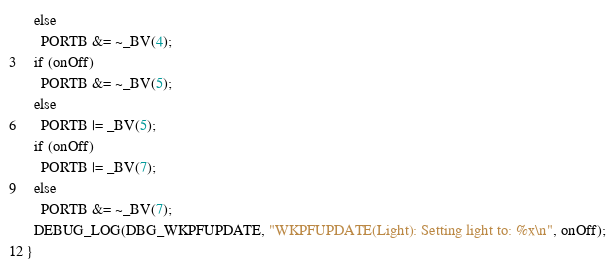<code> <loc_0><loc_0><loc_500><loc_500><_C_>  else
    PORTB &= ~_BV(4);
  if (onOff)
    PORTB &= ~_BV(5);
  else
    PORTB |= _BV(5);
  if (onOff)
    PORTB |= _BV(7);
  else
    PORTB &= ~_BV(7);
  DEBUG_LOG(DBG_WKPFUPDATE, "WKPFUPDATE(Light): Setting light to: %x\n", onOff);
}
</code> 